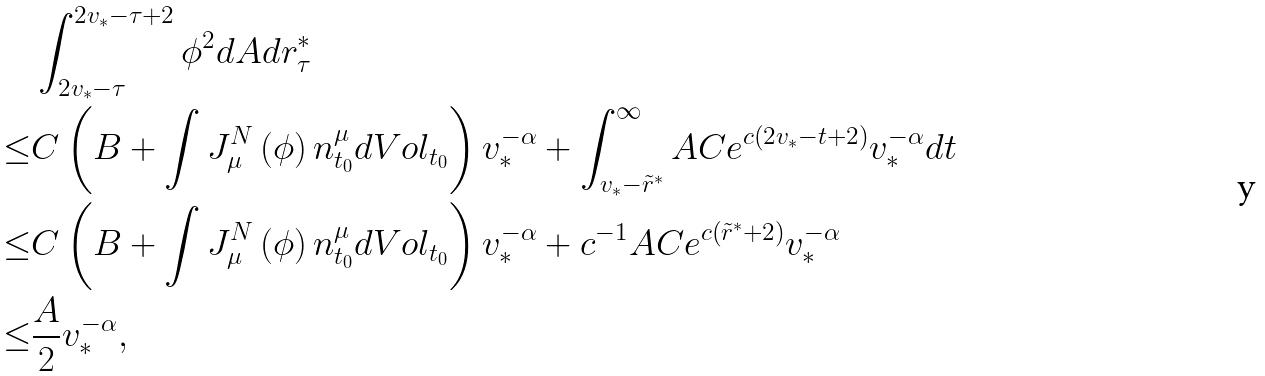<formula> <loc_0><loc_0><loc_500><loc_500>& \int _ { 2 v _ { * } - \tau } ^ { 2 v _ { * } - \tau + 2 } \phi ^ { 2 } d A d r ^ { * } _ { \tau } \\ \leq & C \left ( B + \int J ^ { N } _ { \mu } \left ( \phi \right ) n ^ { \mu } _ { t _ { 0 } } d V o l _ { t _ { 0 } } \right ) v _ { * } ^ { - \alpha } + \int _ { v _ { * } - \tilde { r } ^ { * } } ^ { \infty } A C e ^ { c \left ( 2 v _ { * } - t + 2 \right ) } v _ { * } ^ { - \alpha } d t \\ \leq & C \left ( B + \int J ^ { N } _ { \mu } \left ( \phi \right ) n ^ { \mu } _ { t _ { 0 } } d V o l _ { t _ { 0 } } \right ) v _ { * } ^ { - \alpha } + c ^ { - 1 } A C e ^ { c \left ( \tilde { r } ^ { * } + 2 \right ) } v _ { * } ^ { - \alpha } \\ \leq & \frac { A } { 2 } v _ { * } ^ { - \alpha } ,</formula> 